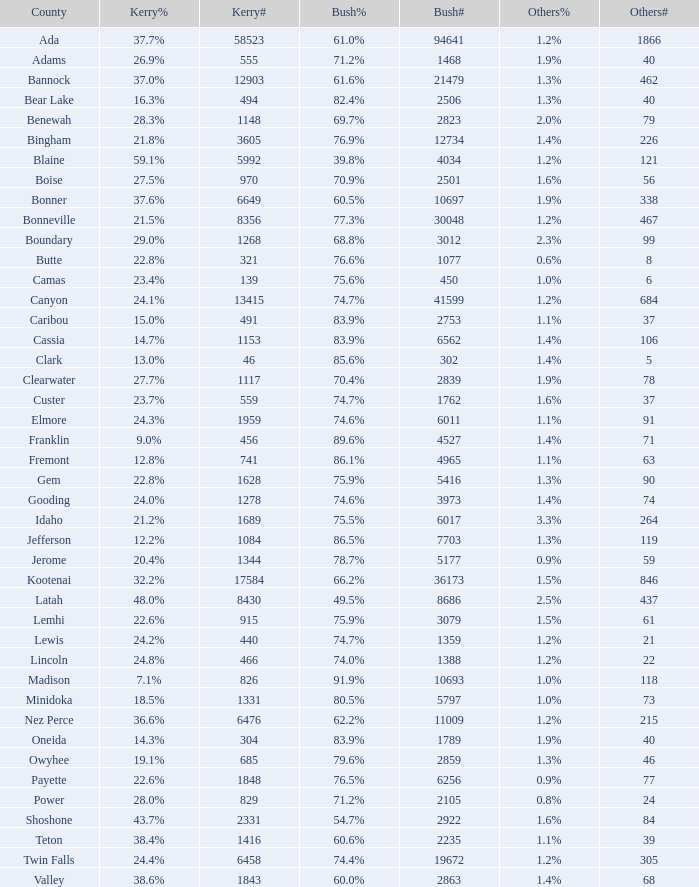How many distinct tallies of votes for bush exist in the county where he received 6 1.0. Would you mind parsing the complete table? {'header': ['County', 'Kerry%', 'Kerry#', 'Bush%', 'Bush#', 'Others%', 'Others#'], 'rows': [['Ada', '37.7%', '58523', '61.0%', '94641', '1.2%', '1866'], ['Adams', '26.9%', '555', '71.2%', '1468', '1.9%', '40'], ['Bannock', '37.0%', '12903', '61.6%', '21479', '1.3%', '462'], ['Bear Lake', '16.3%', '494', '82.4%', '2506', '1.3%', '40'], ['Benewah', '28.3%', '1148', '69.7%', '2823', '2.0%', '79'], ['Bingham', '21.8%', '3605', '76.9%', '12734', '1.4%', '226'], ['Blaine', '59.1%', '5992', '39.8%', '4034', '1.2%', '121'], ['Boise', '27.5%', '970', '70.9%', '2501', '1.6%', '56'], ['Bonner', '37.6%', '6649', '60.5%', '10697', '1.9%', '338'], ['Bonneville', '21.5%', '8356', '77.3%', '30048', '1.2%', '467'], ['Boundary', '29.0%', '1268', '68.8%', '3012', '2.3%', '99'], ['Butte', '22.8%', '321', '76.6%', '1077', '0.6%', '8'], ['Camas', '23.4%', '139', '75.6%', '450', '1.0%', '6'], ['Canyon', '24.1%', '13415', '74.7%', '41599', '1.2%', '684'], ['Caribou', '15.0%', '491', '83.9%', '2753', '1.1%', '37'], ['Cassia', '14.7%', '1153', '83.9%', '6562', '1.4%', '106'], ['Clark', '13.0%', '46', '85.6%', '302', '1.4%', '5'], ['Clearwater', '27.7%', '1117', '70.4%', '2839', '1.9%', '78'], ['Custer', '23.7%', '559', '74.7%', '1762', '1.6%', '37'], ['Elmore', '24.3%', '1959', '74.6%', '6011', '1.1%', '91'], ['Franklin', '9.0%', '456', '89.6%', '4527', '1.4%', '71'], ['Fremont', '12.8%', '741', '86.1%', '4965', '1.1%', '63'], ['Gem', '22.8%', '1628', '75.9%', '5416', '1.3%', '90'], ['Gooding', '24.0%', '1278', '74.6%', '3973', '1.4%', '74'], ['Idaho', '21.2%', '1689', '75.5%', '6017', '3.3%', '264'], ['Jefferson', '12.2%', '1084', '86.5%', '7703', '1.3%', '119'], ['Jerome', '20.4%', '1344', '78.7%', '5177', '0.9%', '59'], ['Kootenai', '32.2%', '17584', '66.2%', '36173', '1.5%', '846'], ['Latah', '48.0%', '8430', '49.5%', '8686', '2.5%', '437'], ['Lemhi', '22.6%', '915', '75.9%', '3079', '1.5%', '61'], ['Lewis', '24.2%', '440', '74.7%', '1359', '1.2%', '21'], ['Lincoln', '24.8%', '466', '74.0%', '1388', '1.2%', '22'], ['Madison', '7.1%', '826', '91.9%', '10693', '1.0%', '118'], ['Minidoka', '18.5%', '1331', '80.5%', '5797', '1.0%', '73'], ['Nez Perce', '36.6%', '6476', '62.2%', '11009', '1.2%', '215'], ['Oneida', '14.3%', '304', '83.9%', '1789', '1.9%', '40'], ['Owyhee', '19.1%', '685', '79.6%', '2859', '1.3%', '46'], ['Payette', '22.6%', '1848', '76.5%', '6256', '0.9%', '77'], ['Power', '28.0%', '829', '71.2%', '2105', '0.8%', '24'], ['Shoshone', '43.7%', '2331', '54.7%', '2922', '1.6%', '84'], ['Teton', '38.4%', '1416', '60.6%', '2235', '1.1%', '39'], ['Twin Falls', '24.4%', '6458', '74.4%', '19672', '1.2%', '305'], ['Valley', '38.6%', '1843', '60.0%', '2863', '1.4%', '68']]} 